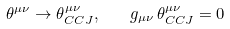<formula> <loc_0><loc_0><loc_500><loc_500>\theta ^ { \mu \nu } \to \theta ^ { \mu \nu } _ { C C J } , \ \ \ g _ { \mu \nu } \, \theta ^ { \mu \nu } _ { C C J } = 0</formula> 